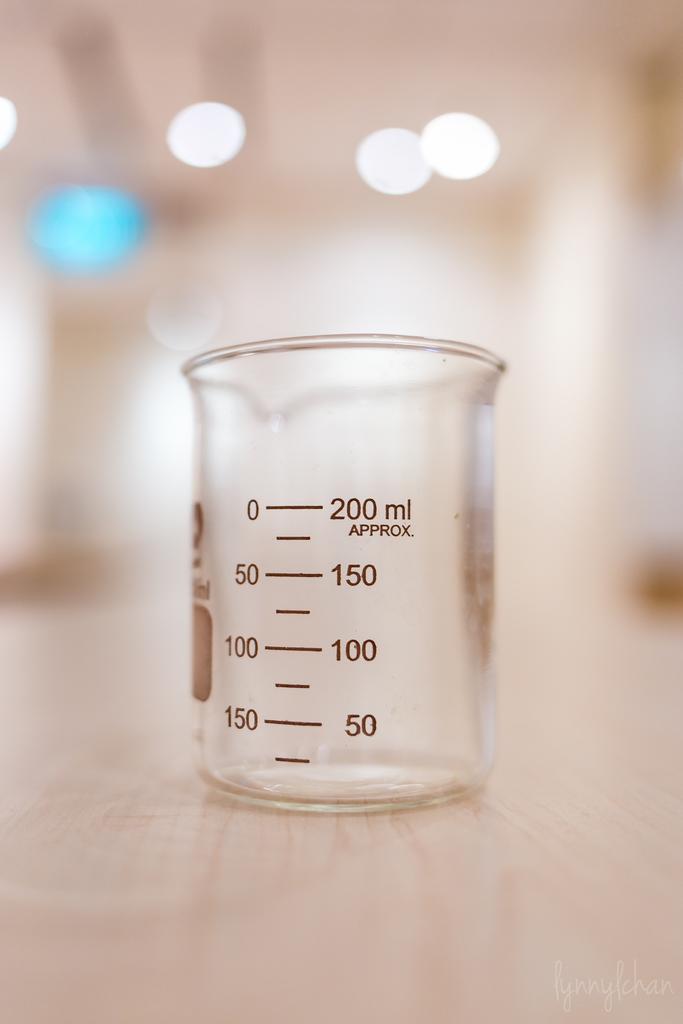Are the measurements on this beaker exact?
Make the answer very short. Yes. What is highest volume this glass mesures?
Provide a succinct answer. 200 ml. 